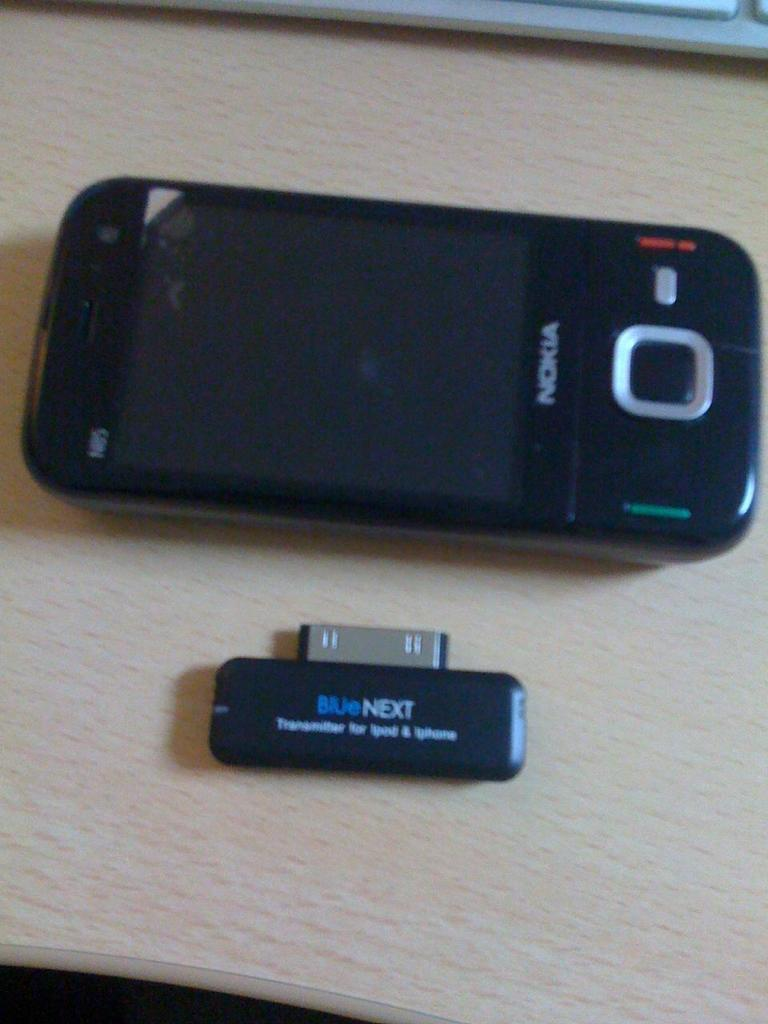<image>
Share a concise interpretation of the image provided. A black Nokia product and an attachment sit on a wood table. 